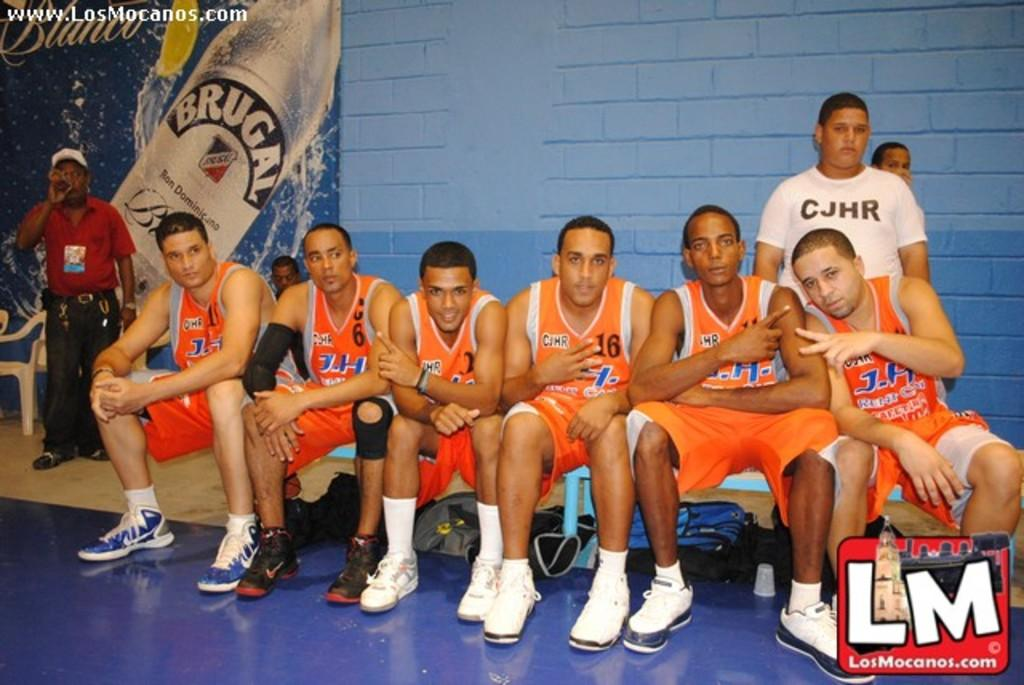<image>
Provide a brief description of the given image. A man wearing a shirt that says CJHR stands behind players wearing orange uniforms 